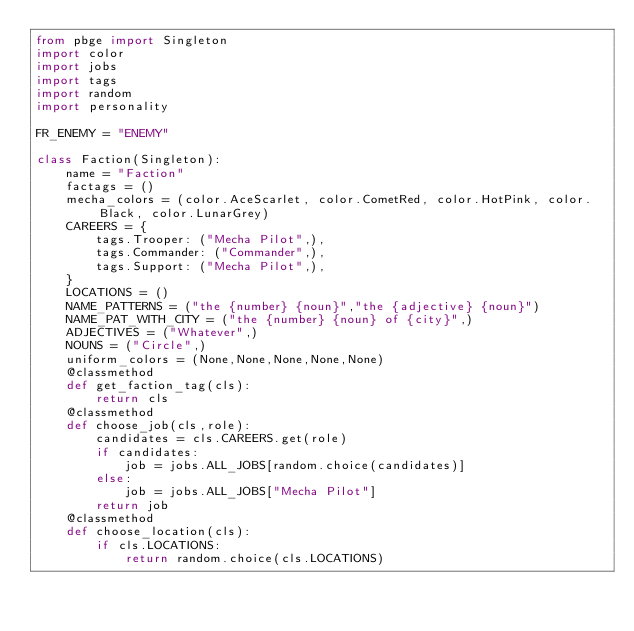<code> <loc_0><loc_0><loc_500><loc_500><_Python_>from pbge import Singleton
import color
import jobs
import tags
import random
import personality

FR_ENEMY = "ENEMY"

class Faction(Singleton):
    name = "Faction"
    factags = ()
    mecha_colors = (color.AceScarlet, color.CometRed, color.HotPink, color.Black, color.LunarGrey)
    CAREERS = {
        tags.Trooper: ("Mecha Pilot",),
        tags.Commander: ("Commander",),
        tags.Support: ("Mecha Pilot",),
    }
    LOCATIONS = ()
    NAME_PATTERNS = ("the {number} {noun}","the {adjective} {noun}")
    NAME_PAT_WITH_CITY = ("the {number} {noun} of {city}",)
    ADJECTIVES = ("Whatever",)
    NOUNS = ("Circle",)
    uniform_colors = (None,None,None,None,None)
    @classmethod
    def get_faction_tag(cls):
        return cls
    @classmethod
    def choose_job(cls,role):
        candidates = cls.CAREERS.get(role)
        if candidates:
            job = jobs.ALL_JOBS[random.choice(candidates)]
        else:
            job = jobs.ALL_JOBS["Mecha Pilot"]
        return job
    @classmethod
    def choose_location(cls):
        if cls.LOCATIONS:
            return random.choice(cls.LOCATIONS)</code> 